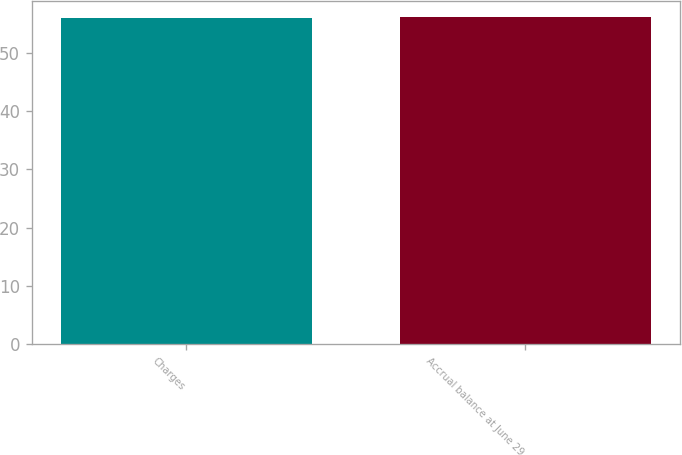<chart> <loc_0><loc_0><loc_500><loc_500><bar_chart><fcel>Charges<fcel>Accrual balance at June 29<nl><fcel>56<fcel>56.1<nl></chart> 